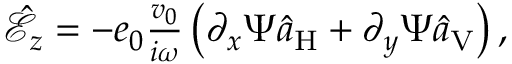<formula> <loc_0><loc_0><loc_500><loc_500>\begin{array} { r } { \hat { \mathcal { E } } _ { z } = - e _ { 0 } \frac { v _ { 0 } } { i \omega } \left ( \partial _ { x } \Psi \hat { a } _ { H } + \partial _ { y } \Psi \hat { a } _ { V } \right ) , } \end{array}</formula> 